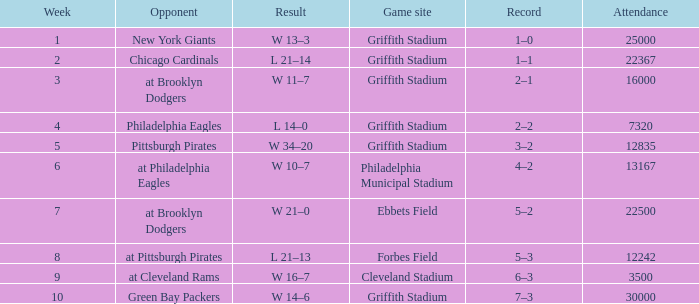In week 9 who were the opponent?  At cleveland rams. Give me the full table as a dictionary. {'header': ['Week', 'Opponent', 'Result', 'Game site', 'Record', 'Attendance'], 'rows': [['1', 'New York Giants', 'W 13–3', 'Griffith Stadium', '1–0', '25000'], ['2', 'Chicago Cardinals', 'L 21–14', 'Griffith Stadium', '1–1', '22367'], ['3', 'at Brooklyn Dodgers', 'W 11–7', 'Griffith Stadium', '2–1', '16000'], ['4', 'Philadelphia Eagles', 'L 14–0', 'Griffith Stadium', '2–2', '7320'], ['5', 'Pittsburgh Pirates', 'W 34–20', 'Griffith Stadium', '3–2', '12835'], ['6', 'at Philadelphia Eagles', 'W 10–7', 'Philadelphia Municipal Stadium', '4–2', '13167'], ['7', 'at Brooklyn Dodgers', 'W 21–0', 'Ebbets Field', '5–2', '22500'], ['8', 'at Pittsburgh Pirates', 'L 21–13', 'Forbes Field', '5–3', '12242'], ['9', 'at Cleveland Rams', 'W 16–7', 'Cleveland Stadium', '6–3', '3500'], ['10', 'Green Bay Packers', 'W 14–6', 'Griffith Stadium', '7–3', '30000']]} 